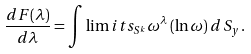Convert formula to latex. <formula><loc_0><loc_0><loc_500><loc_500>\frac { d F ( \lambda ) } { d \lambda } = \int \lim i t s _ { S ^ { k } } \omega ^ { \lambda } \, ( \ln \omega ) \, d \, S _ { y } \, .</formula> 